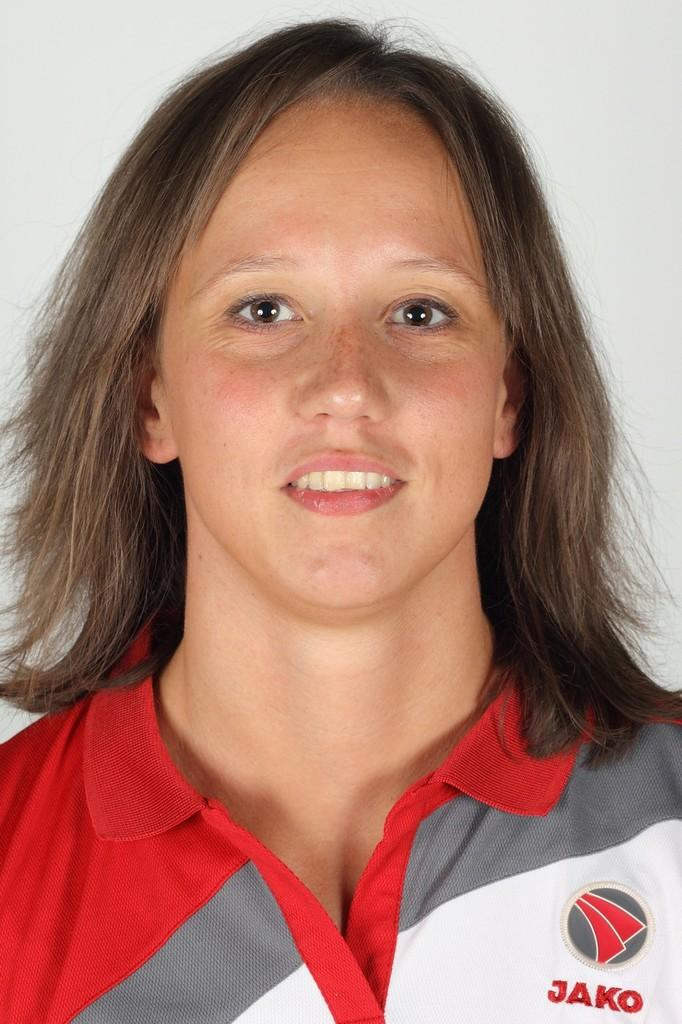<image>
Summarize the visual content of the image. A girl with brown eyes wearing a shirt that has Jaco on the front. 